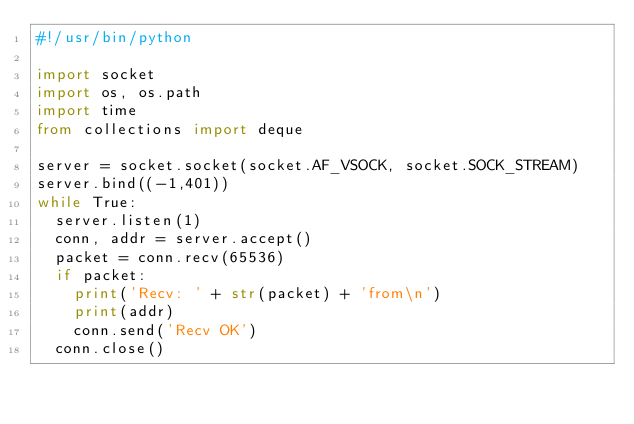Convert code to text. <code><loc_0><loc_0><loc_500><loc_500><_Python_>#!/usr/bin/python

import socket
import os, os.path
import time
from collections import deque

server = socket.socket(socket.AF_VSOCK, socket.SOCK_STREAM)
server.bind((-1,401))
while True:
  server.listen(1)
  conn, addr = server.accept()
  packet = conn.recv(65536)
  if packet:
    print('Recv: ' + str(packet) + 'from\n')
    print(addr)
    conn.send('Recv OK')
  conn.close()
</code> 